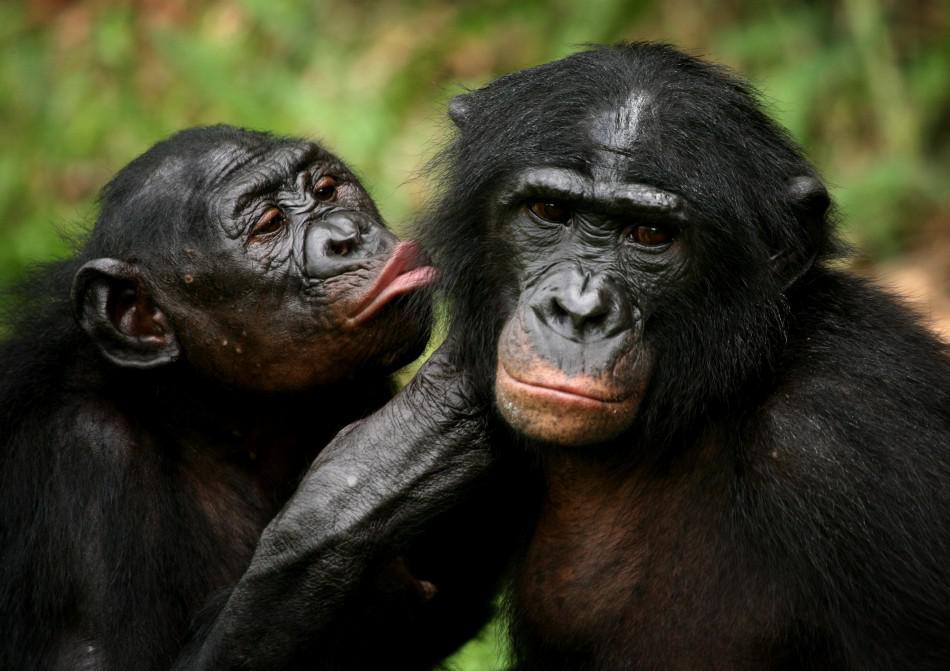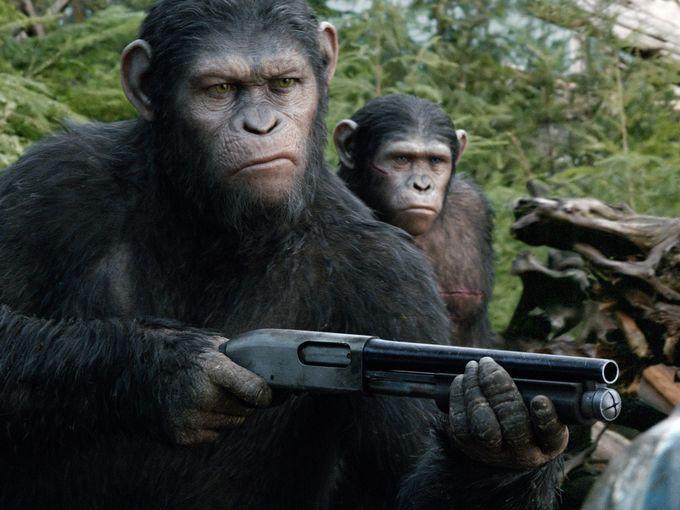The first image is the image on the left, the second image is the image on the right. For the images displayed, is the sentence "There is one gorilla with its mouth wide open showing all of its teeth." factually correct? Answer yes or no. No. The first image is the image on the left, the second image is the image on the right. Evaluate the accuracy of this statement regarding the images: "Each image shows just one ape, and one of the apes has an open mouth.". Is it true? Answer yes or no. No. 